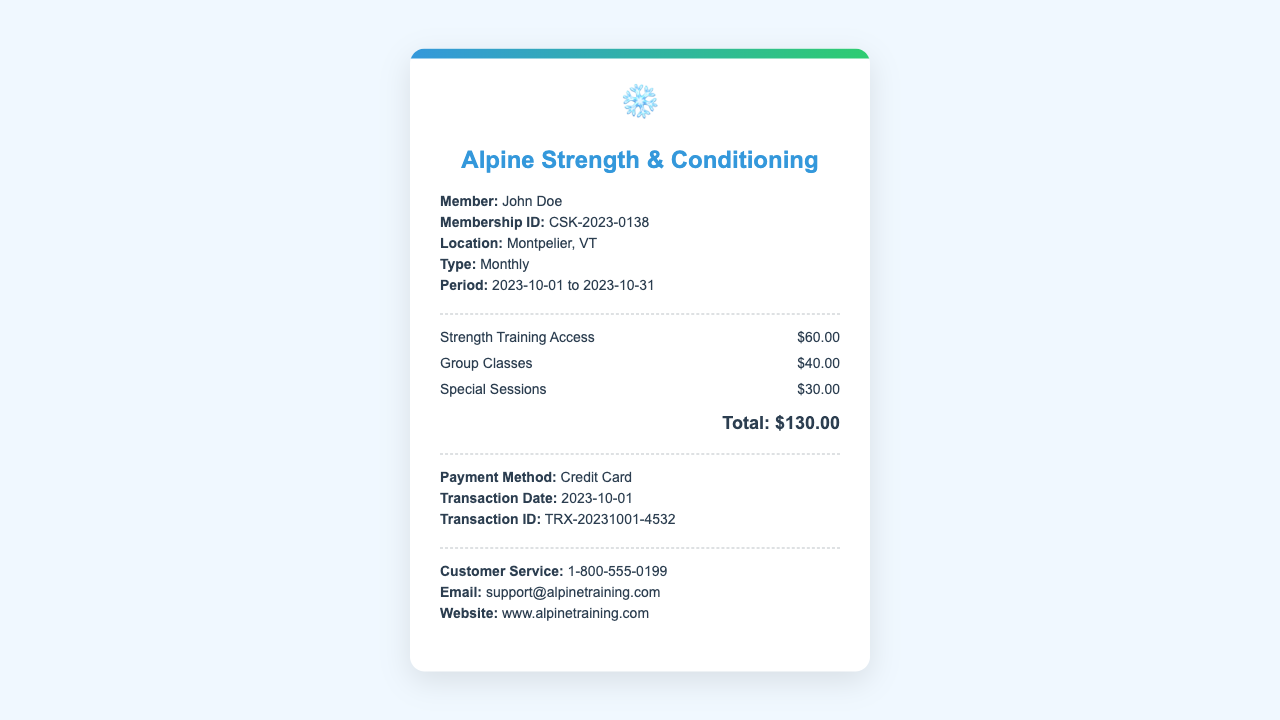What is the member's name? The member's name is listed in the details section of the receipt.
Answer: John Doe What is the total charge for the month? The total charge is the summation of all charges listed in the charges section.
Answer: $130.00 What is the membership ID? The membership ID is a unique identifier for the member found in the details section.
Answer: CSK-2023-0138 When does the membership period start? The start date of the membership period is indicated in the details section.
Answer: 2023-10-01 What is the payment method used? The payment method is mentioned in the payment section of the document.
Answer: Credit Card How much is charged for group classes? The fee for group classes is specified in the charges section of the receipt.
Answer: $40.00 What additional service has a cost of $30.00? This amount is specified for a particular service listed under charges.
Answer: Special Sessions What is the location of the gym? The location of the gym is provided in the details section of the receipt.
Answer: Montpelier, VT How can I contact customer service? Contact information for customer service is provided at the end of the receipt.
Answer: 1-800-555-0199 